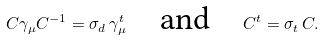Convert formula to latex. <formula><loc_0><loc_0><loc_500><loc_500>C \gamma _ { \mu } C ^ { - 1 } = \sigma _ { d } \, \gamma _ { \mu } ^ { t } \quad \text {and} \quad C ^ { t } = \sigma _ { t } \, C .</formula> 